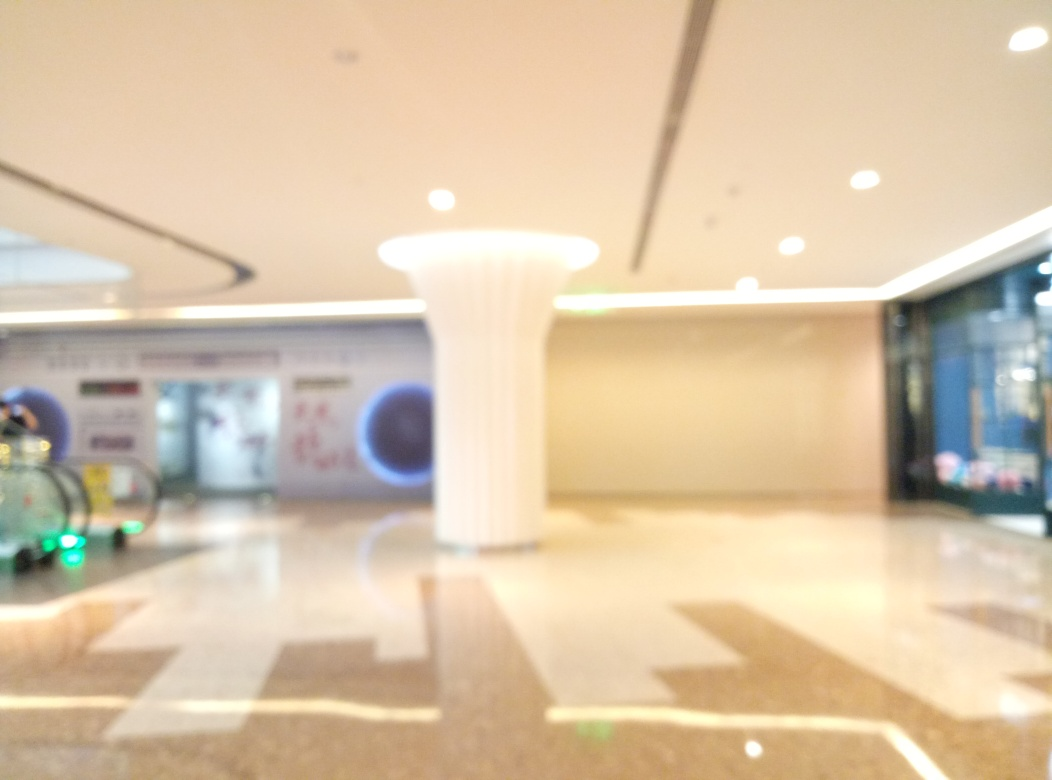What can be said about the lighting in this space? The lighting in the space is diffused and evenly distributed, with no harsh shadows visible. Overhead lighting fixtures provide a bright ambiance, which reflects off the shiny floor surface, contributing to the overall modern and welcoming atmosphere. 